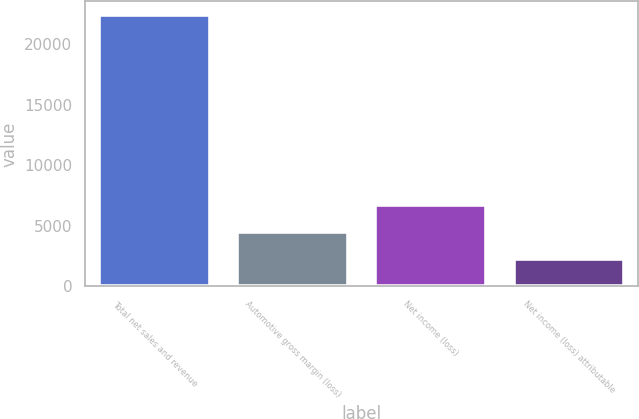<chart> <loc_0><loc_0><loc_500><loc_500><bar_chart><fcel>Total net sales and revenue<fcel>Automotive gross margin (loss)<fcel>Net income (loss)<fcel>Net income (loss) attributable<nl><fcel>22431<fcel>4494.02<fcel>6736.14<fcel>2251.9<nl></chart> 